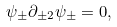<formula> <loc_0><loc_0><loc_500><loc_500>\psi _ { \pm } \partial _ { \pm 2 } \psi _ { \pm } = 0 ,</formula> 